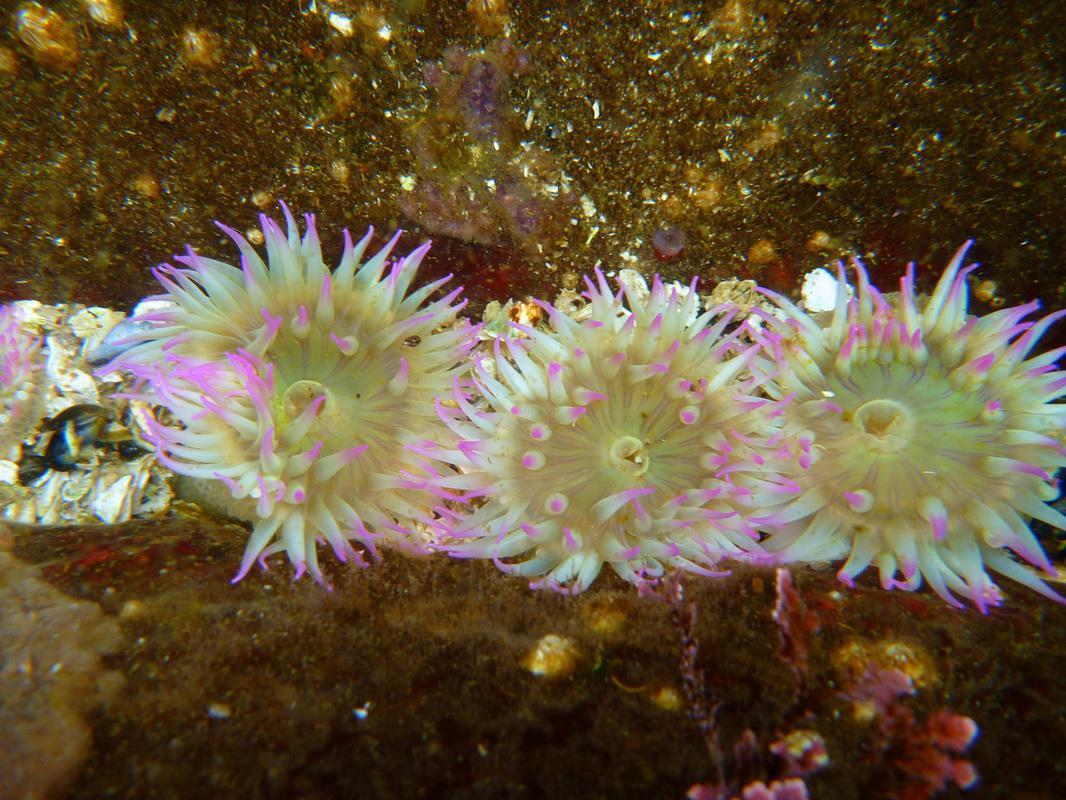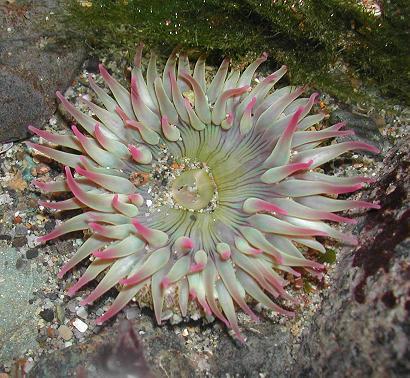The first image is the image on the left, the second image is the image on the right. Assess this claim about the two images: "The trunk of the anemone can be seen in one of the images.". Correct or not? Answer yes or no. No. The first image is the image on the left, the second image is the image on the right. Assess this claim about the two images: "The sea creature in the right photo has white tentacles with pink tips.". Correct or not? Answer yes or no. Yes. 